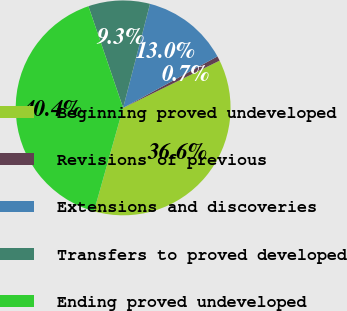Convert chart. <chart><loc_0><loc_0><loc_500><loc_500><pie_chart><fcel>Beginning proved undeveloped<fcel>Revisions of previous<fcel>Extensions and discoveries<fcel>Transfers to proved developed<fcel>Ending proved undeveloped<nl><fcel>36.62%<fcel>0.71%<fcel>13.02%<fcel>9.26%<fcel>40.39%<nl></chart> 